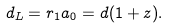Convert formula to latex. <formula><loc_0><loc_0><loc_500><loc_500>d _ { L } = r _ { 1 } a _ { 0 } = d ( 1 + z ) .</formula> 